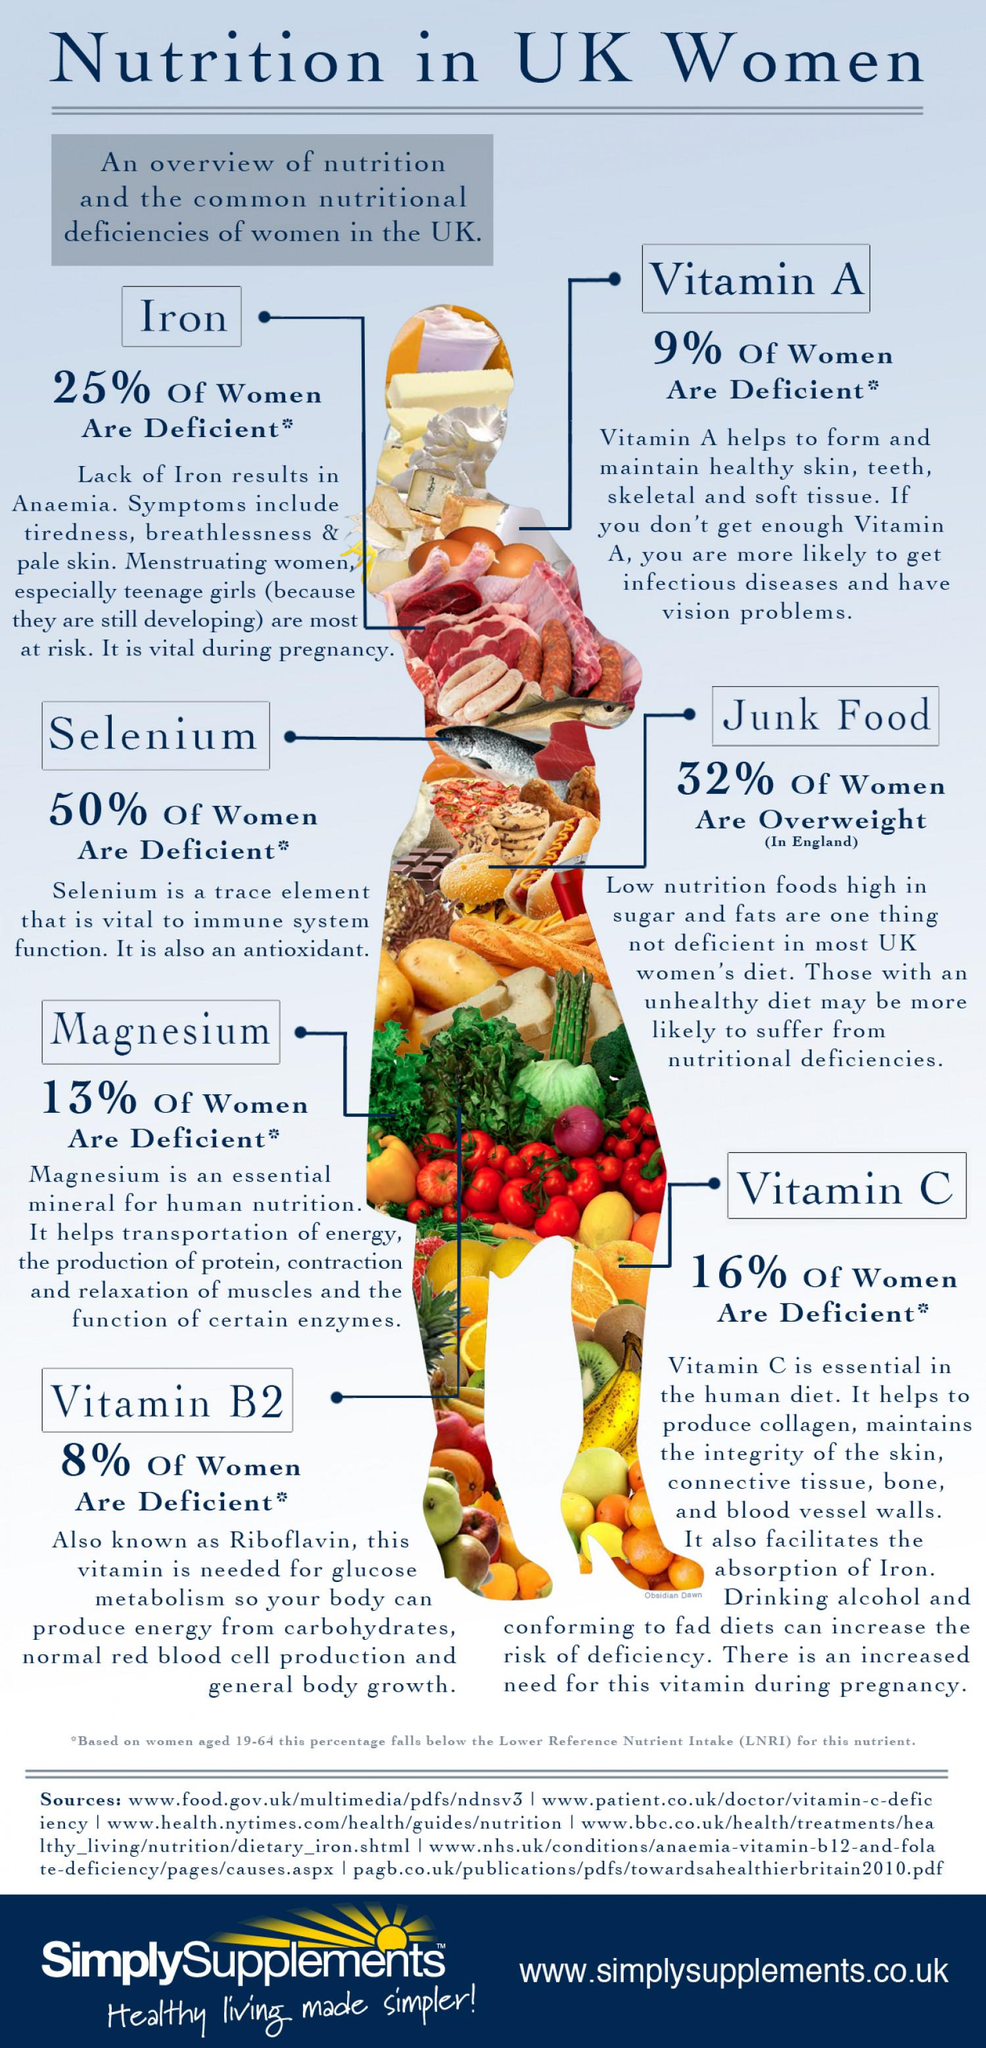Point out several critical features in this image. In the UK, 75% of women do not have iron deficiency. In the United Kingdom, approximately 16% of women are deficient in Vitamin C. Vitamin B2 is also known as riboflavin. According to data from England, 68% of women are not overweight. According to recent data, only 9% of women in the United Kingdom are deficient in Vitamin A. 